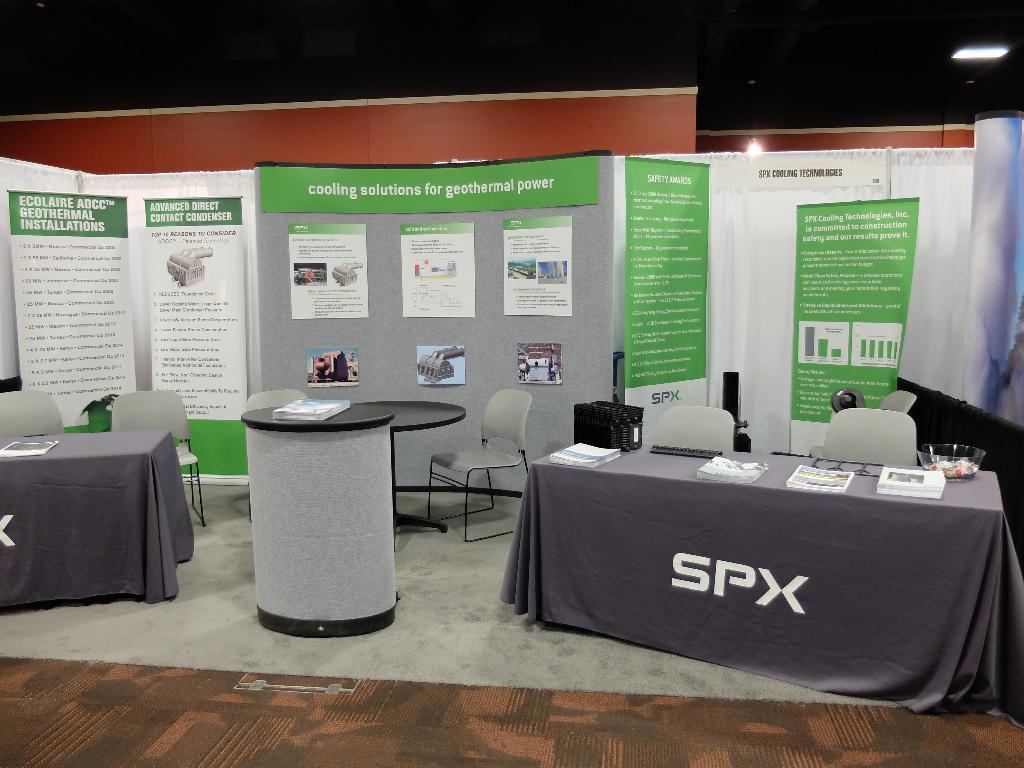Please provide a concise description of this image. Here in this picture we can see tables and chairs present on the floor and behind that we can see banners and posters present over there and we can also see lights present on the roof and we can see some books present on the tables. 